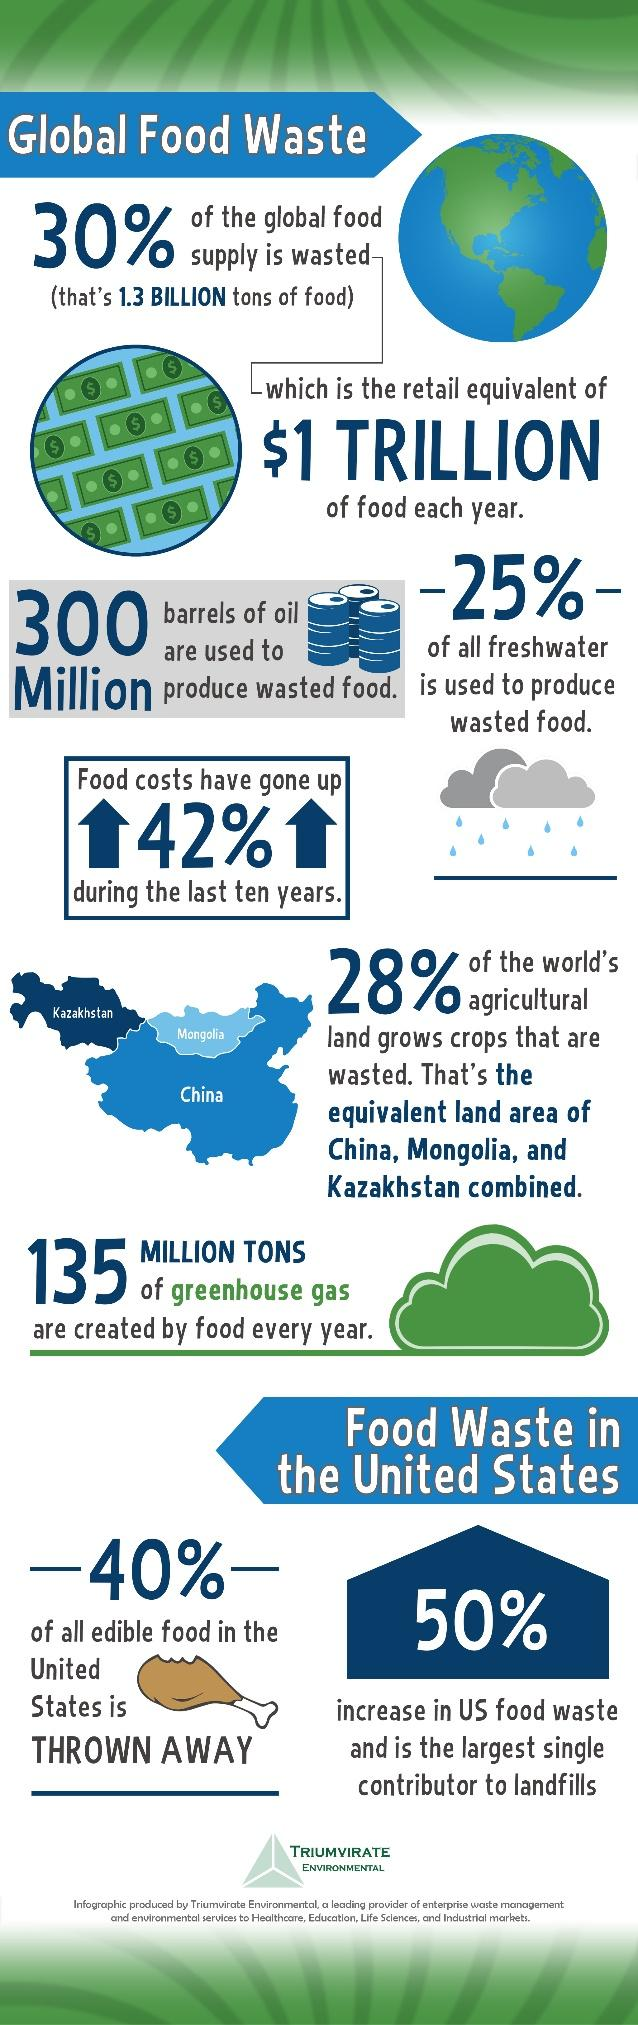Indicate a few pertinent items in this graphic. The percentage increase in US food waste is 42%, 50%, or 40%, depending on the specific year or time period considered. According to estimates, the amount of arable land used to cultivate wasted crops is equivalent to the size of three entire countries. 